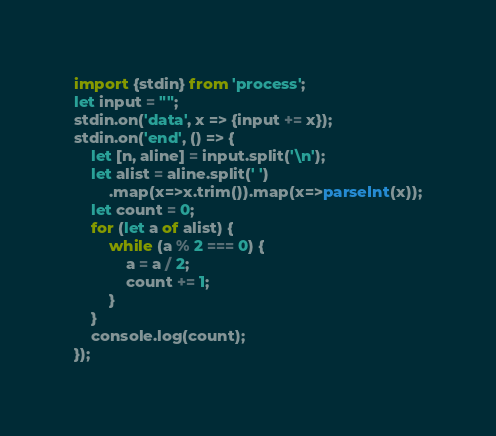Convert code to text. <code><loc_0><loc_0><loc_500><loc_500><_TypeScript_>import {stdin} from 'process';
let input = "";
stdin.on('data', x => {input += x});
stdin.on('end', () => {
    let [n, aline] = input.split('\n');
    let alist = aline.split(' ')
        .map(x=>x.trim()).map(x=>parseInt(x));
    let count = 0;
    for (let a of alist) {
        while (a % 2 === 0) {
            a = a / 2;
            count += 1;
        }
    }
    console.log(count);
});</code> 